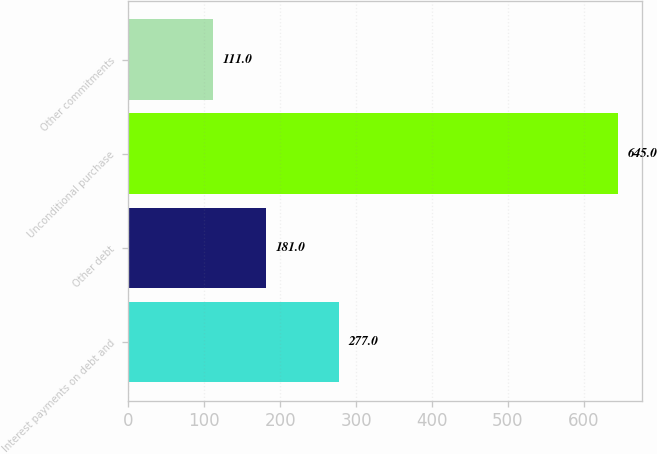Convert chart. <chart><loc_0><loc_0><loc_500><loc_500><bar_chart><fcel>Interest payments on debt and<fcel>Other debt<fcel>Unconditional purchase<fcel>Other commitments<nl><fcel>277<fcel>181<fcel>645<fcel>111<nl></chart> 